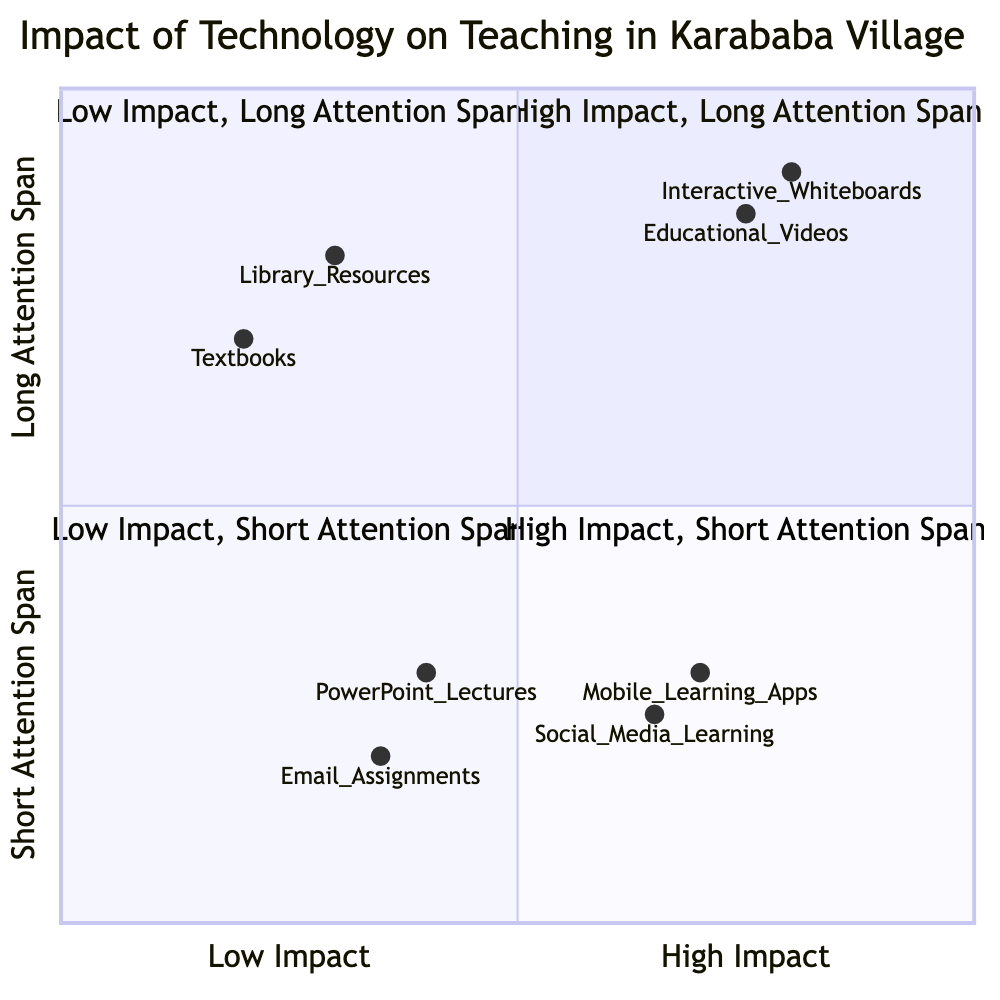What elements are in the "High Impact, Long Attention Span" quadrant? The "High Impact, Long Attention Span" quadrant includes "Interactive Whiteboards" and "Educational Videos."
Answer: Interactive Whiteboards, Educational Videos Which quadrant contains "Textbooks"? "Textbooks" are located in the "Low Impact, Long Attention Span" quadrant.
Answer: Low Impact, Long Attention Span How many elements are classified as "Low Impact, Short Attention Span"? There are two elements classified as "Low Impact, Short Attention Span": "PowerPoint Lectures" and "E-mail Assignments."
Answer: 2 Which technology has the highest impact on student attention span? The element with the highest impact on student attention span is "Interactive Whiteboards," located in the "High Impact, Long Attention Span" quadrant.
Answer: Interactive Whiteboards Do any of the elements in the "High Impact, Short Attention Span" quadrant have a description that mentions a risk? Yes, both "Mobile Learning Apps" and "Social Media-based Learning" mention risks associated with distractions or off-task behavior.
Answer: Yes How do "Library Resources" compare with "PowerPoint Lectures" in terms of impact and attention span? "Library Resources" are in the "Low Impact, Long Attention Span" quadrant, while "PowerPoint Lectures" are in the "Low Impact, Short Attention Span" quadrant, indicating that library resources have a longer attention span despite both having low impact.
Answer: Longer attention span Which element has the lowest impact according to the diagram? The element with the lowest impact is "Email Assignments," located in the "Low Impact, Short Attention Span" quadrant.
Answer: Email Assignments Which quadrant features the element "Social Media-based Learning"? "Social Media-based Learning" is positioned in the "High Impact, Short Attention Span" quadrant.
Answer: High Impact, Short Attention Span What is the attention span description for "Educational Videos"? The attention span description for "Educational Videos" is categorized as long.
Answer: Long 